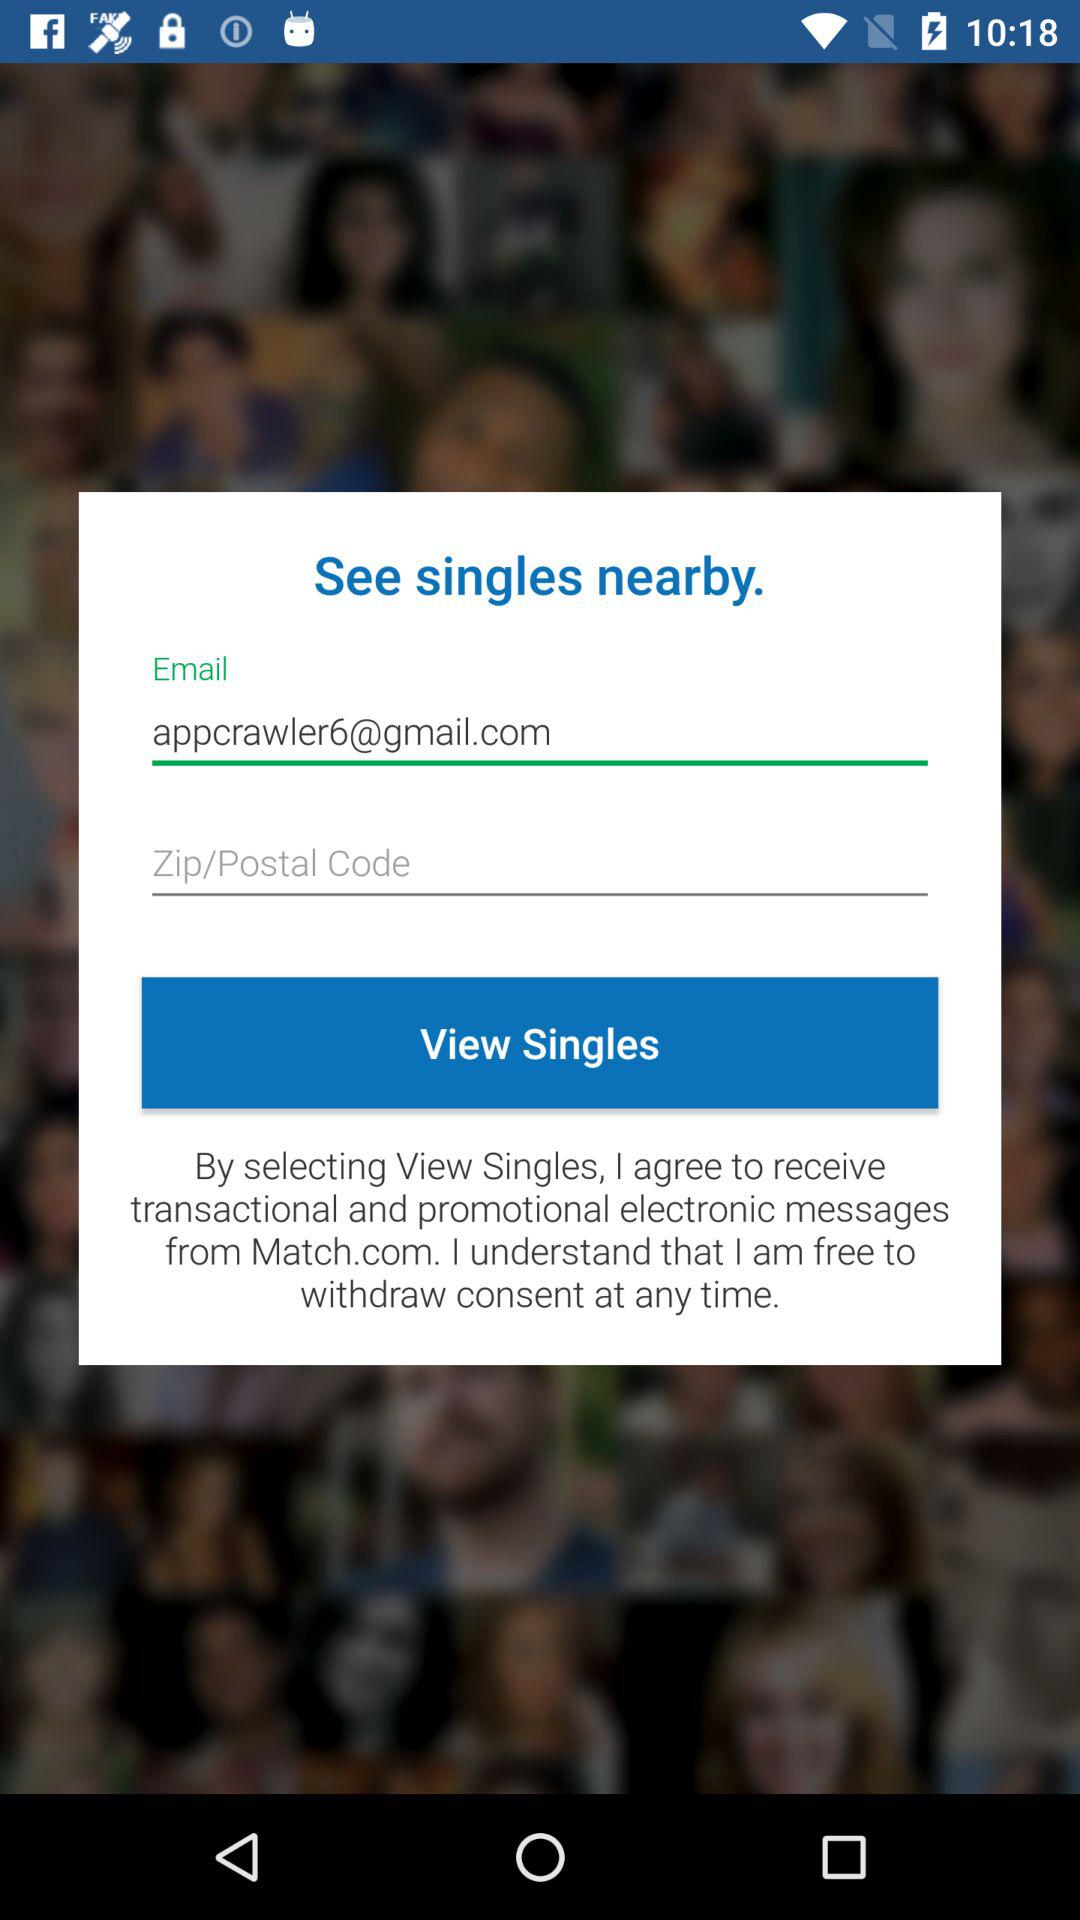What is an email address? The email address is appcrawler6@gmail.com. 